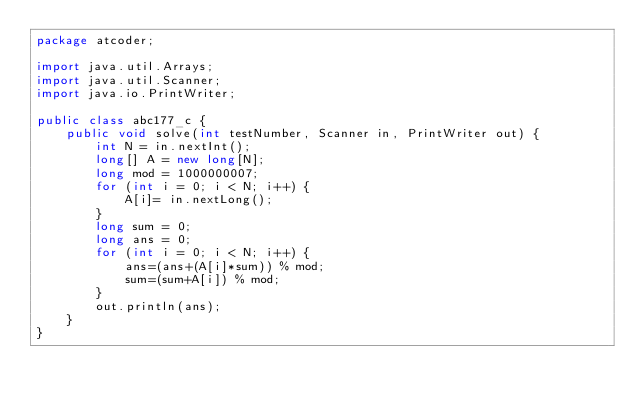Convert code to text. <code><loc_0><loc_0><loc_500><loc_500><_Java_>package atcoder;

import java.util.Arrays;
import java.util.Scanner;
import java.io.PrintWriter;

public class abc177_c {
    public void solve(int testNumber, Scanner in, PrintWriter out) {
        int N = in.nextInt();
        long[] A = new long[N];
        long mod = 1000000007;
        for (int i = 0; i < N; i++) {
            A[i]= in.nextLong();
        }
        long sum = 0;
        long ans = 0;
        for (int i = 0; i < N; i++) {
            ans=(ans+(A[i]*sum)) % mod;
            sum=(sum+A[i]) % mod;
        }
        out.println(ans);
    }
}
</code> 